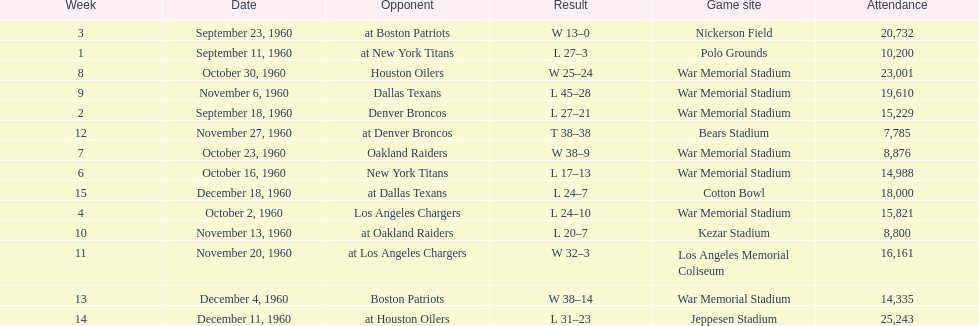The total number of games played at war memorial stadium was how many? 7. 